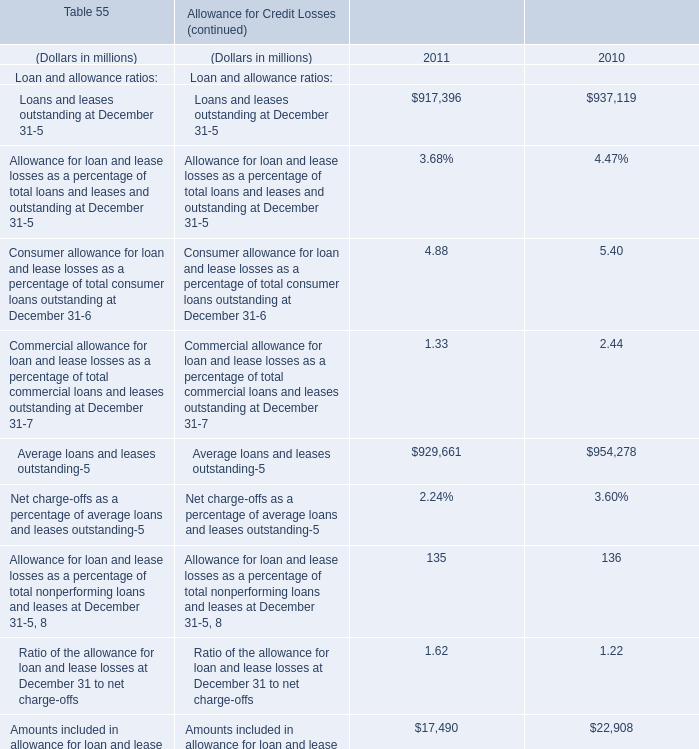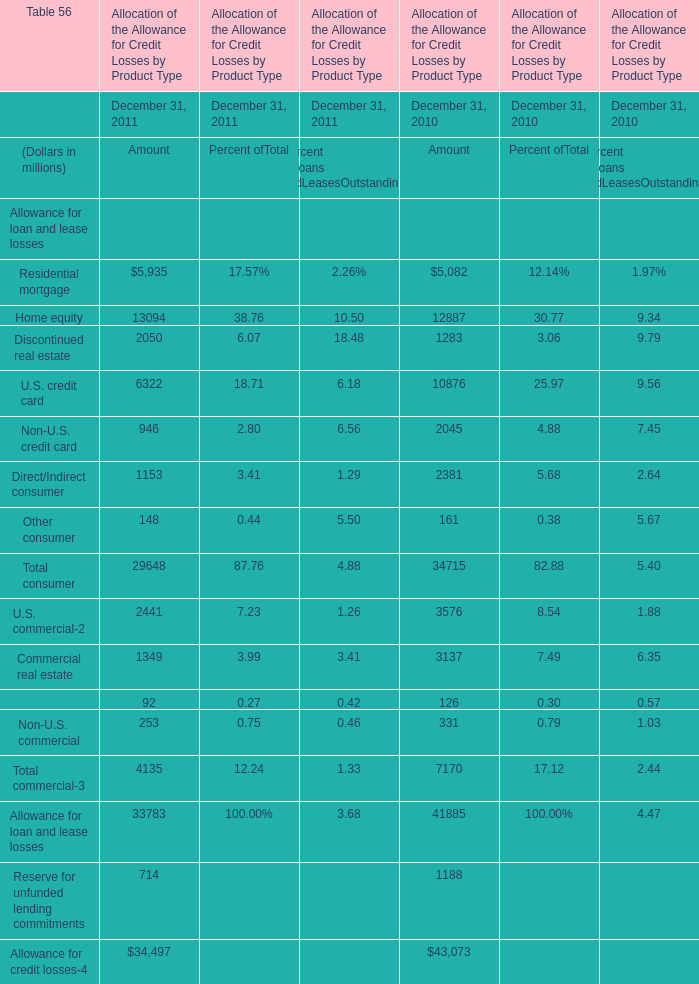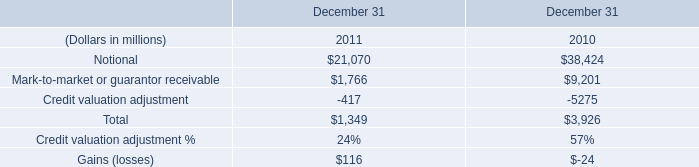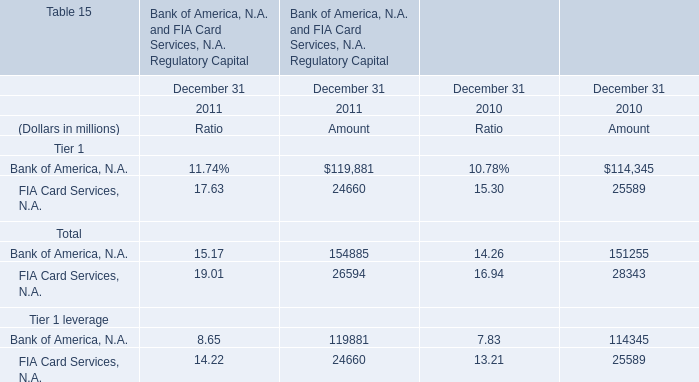If Average loans and leases outstanding develops with the same growth rate in 2011, what will it reach in 2012? (in million) 
Computations: (929661 * (1 + ((929661 - 954278) / 954278)))
Answer: 905679.0316. 